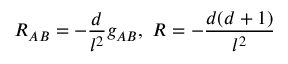<formula> <loc_0><loc_0><loc_500><loc_500>R _ { A B } = - \frac { d } { l ^ { 2 } } g _ { A B } , \, R = - \frac { d ( d + 1 ) } { l ^ { 2 } }</formula> 